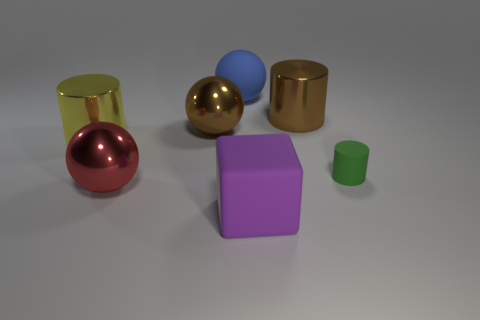Subtract all big yellow cylinders. How many cylinders are left? 2 Add 2 yellow matte objects. How many objects exist? 9 Subtract all brown spheres. How many spheres are left? 2 Subtract 2 spheres. How many spheres are left? 1 Subtract all blocks. How many objects are left? 6 Add 3 gray rubber objects. How many gray rubber objects exist? 3 Subtract 1 red spheres. How many objects are left? 6 Subtract all blue blocks. Subtract all green balls. How many blocks are left? 1 Subtract all cyan spheres. How many yellow cylinders are left? 1 Subtract all large gray balls. Subtract all large brown balls. How many objects are left? 6 